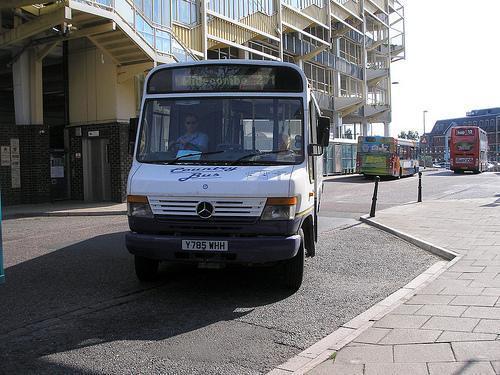How many buses are shown?
Give a very brief answer. 3. 